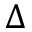<formula> <loc_0><loc_0><loc_500><loc_500>\Delta</formula> 